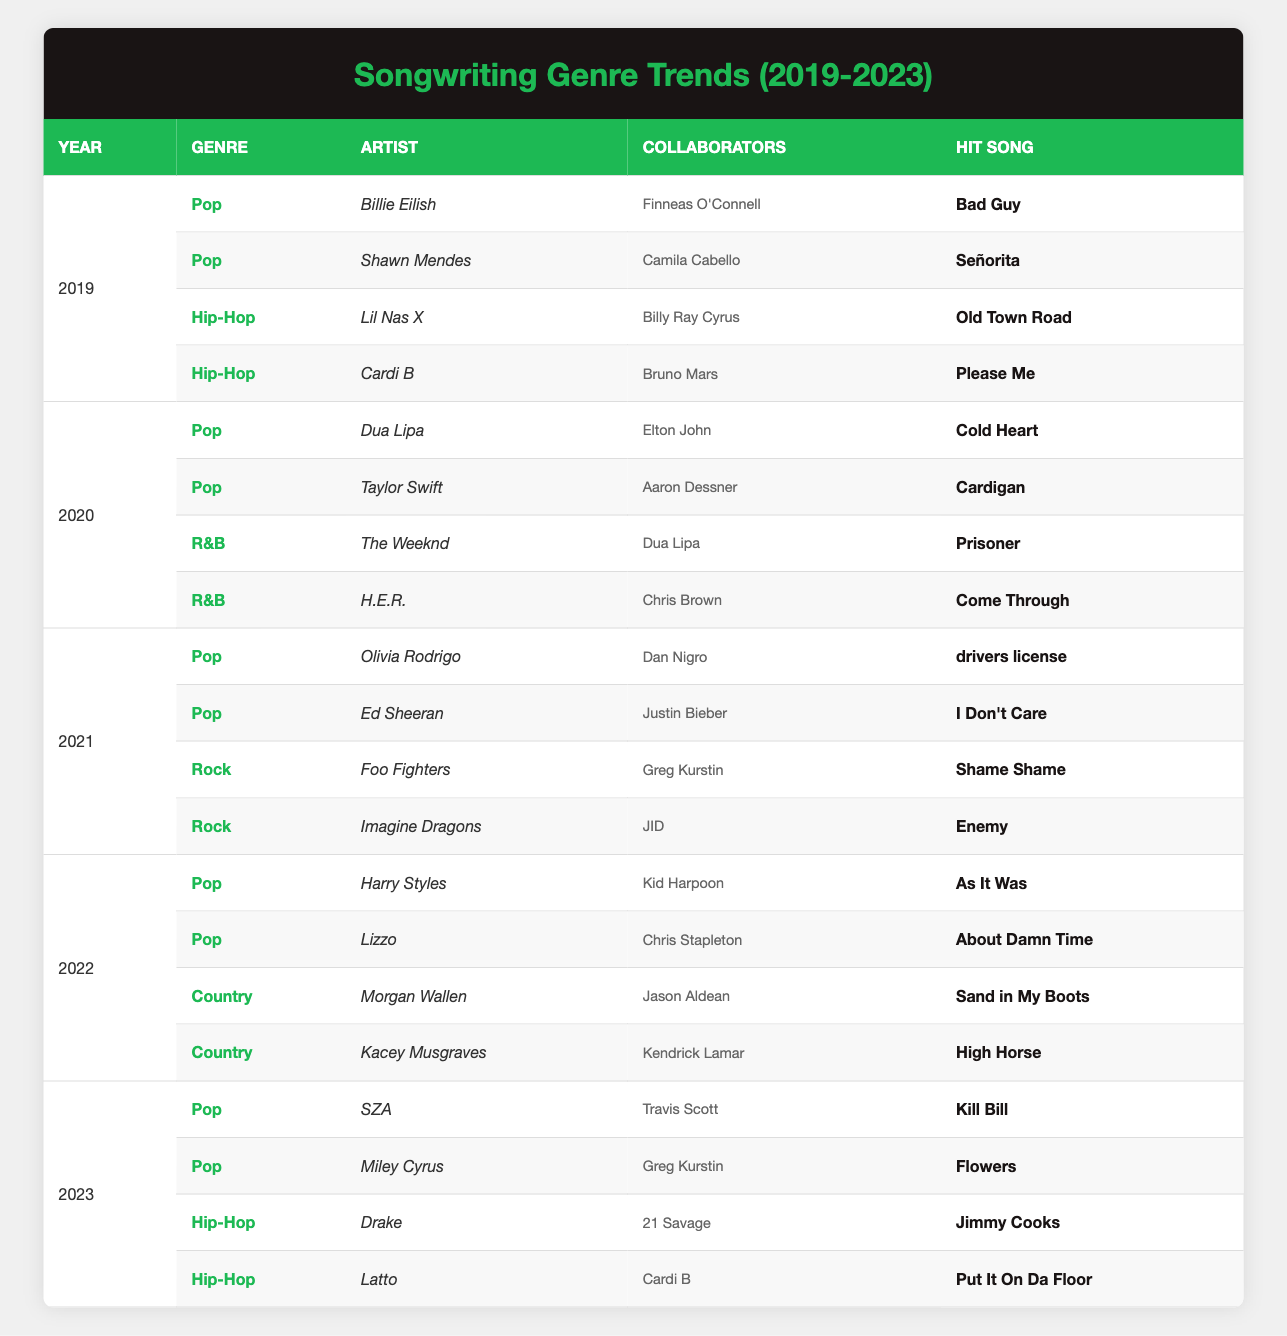What are the hit songs by Billie Eilish and Shawn Mendes in 2019? Billie Eilish's hit song is "Bad Guy," and Shawn Mendes's hit song is "Señorita." Both songs are listed under the Pop genre for the year 2019 in the table.
Answer: Bad Guy, Señorita Which artist collaborated with Dua Lipa in 2020? The table shows that Dua Lipa collaborated with Elton John in 2020. This collaboration is listed under the Pop genre.
Answer: Elton John What genre had the most hit songs in 2021? In 2021, the Pop genre had four hit songs compared to Rock with two hit songs. This indicates that Pop was the most prominent genre that year.
Answer: Pop Did Kacey Musgraves collaborate with Jason Aldean in 2022? No, Kacey Musgraves collaborated with Kendrick Lamar in 2022. This can be confirmed by checking the collaboration details listed under the Country genre for that year.
Answer: No What is the average number of collaborators per artist across all years in the table? Each artist listed has a set number of collaborators (1 per artist in these cases). There are a total of 8 artists across five years, each having a single collaborator. Hence, the total is 8 collaborators for 8 artists, leading to an average of 1 collaborator per artist.
Answer: 1 